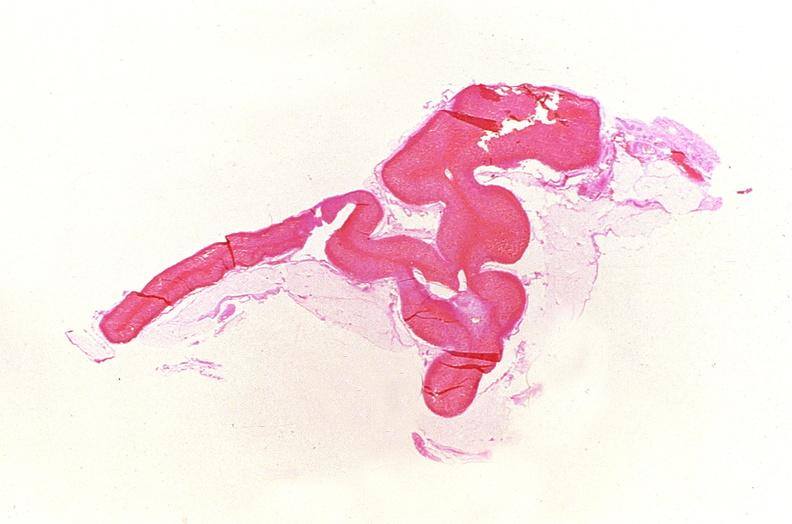what does this image show?
Answer the question using a single word or phrase. Adrenal gland 